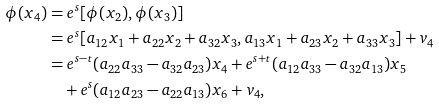Convert formula to latex. <formula><loc_0><loc_0><loc_500><loc_500>\phi ( x _ { 4 } ) & = e ^ { s } [ \phi ( x _ { 2 } ) , \phi ( x _ { 3 } ) ] \\ & = e ^ { s } [ a _ { 1 2 } x _ { 1 } + a _ { 2 2 } x _ { 2 } + a _ { 3 2 } x _ { 3 } , a _ { 1 3 } x _ { 1 } + a _ { 2 3 } x _ { 2 } + a _ { 3 3 } x _ { 3 } ] + v _ { 4 } \\ & = e ^ { s - t } ( a _ { 2 2 } a _ { 3 3 } - a _ { 3 2 } a _ { 2 3 } ) x _ { 4 } + e ^ { s + t } ( a _ { 1 2 } a _ { 3 3 } - a _ { 3 2 } a _ { 1 3 } ) x _ { 5 } \\ & \quad + e ^ { s } ( a _ { 1 2 } a _ { 2 3 } - a _ { 2 2 } a _ { 1 3 } ) x _ { 6 } + v _ { 4 } ,</formula> 